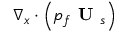<formula> <loc_0><loc_0><loc_500><loc_500>\nabla _ { x } \cdot \left ( p _ { f } U _ { s } \right )</formula> 